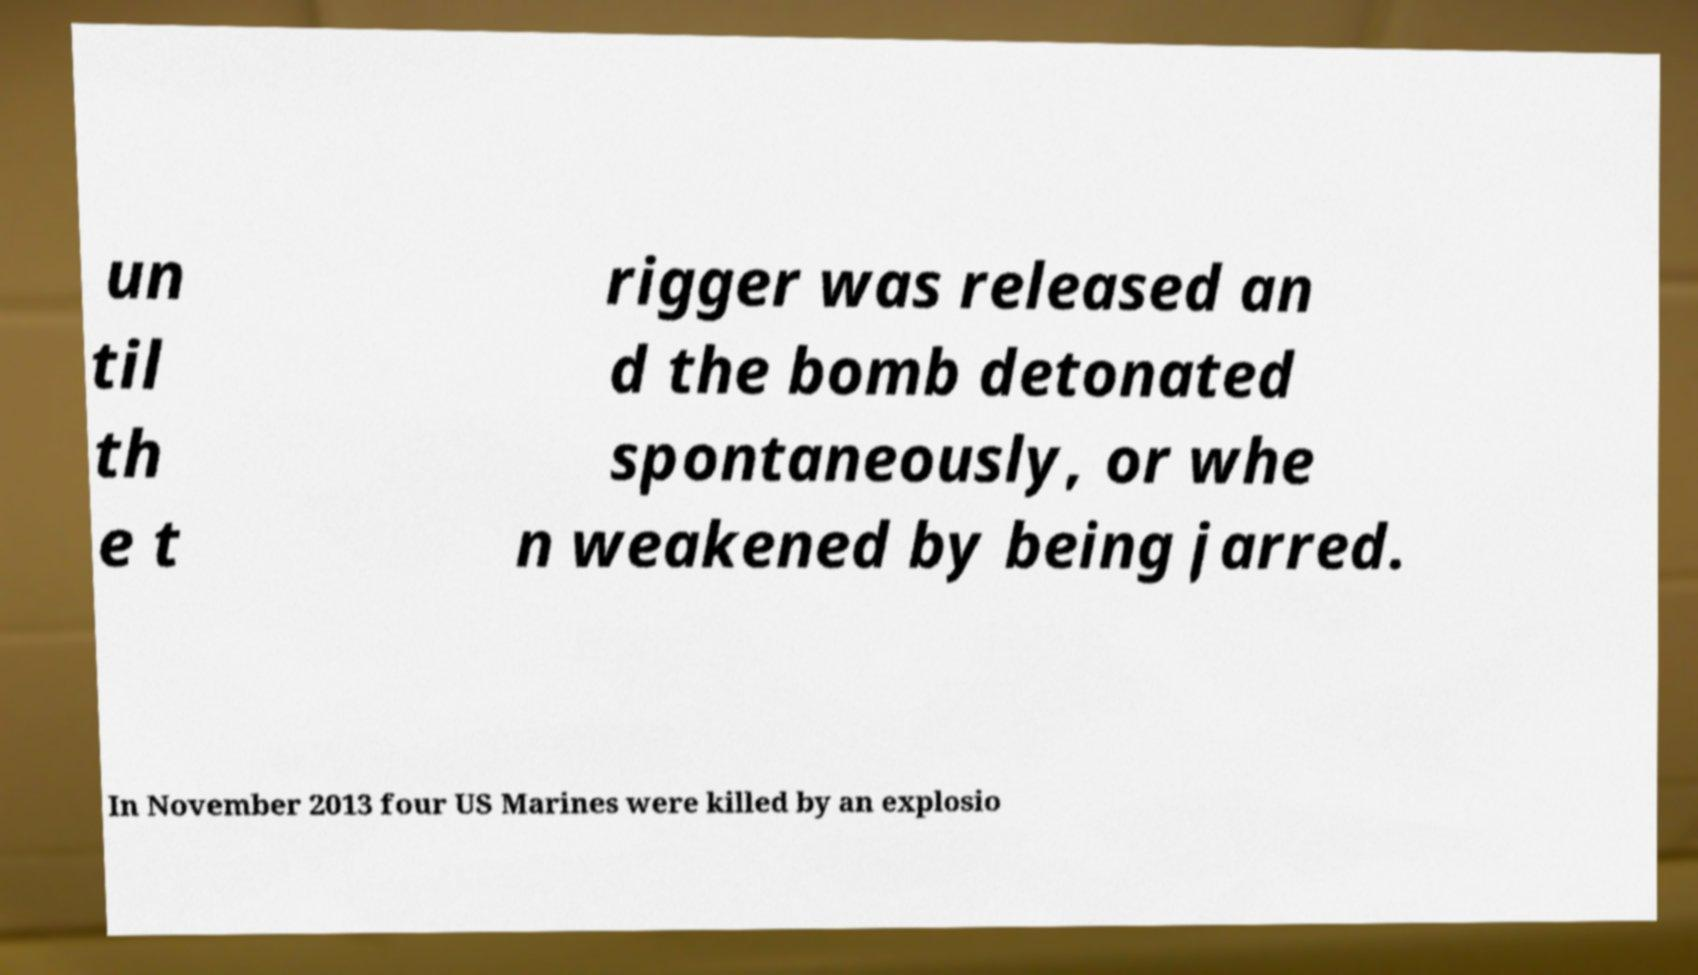Can you read and provide the text displayed in the image?This photo seems to have some interesting text. Can you extract and type it out for me? un til th e t rigger was released an d the bomb detonated spontaneously, or whe n weakened by being jarred. In November 2013 four US Marines were killed by an explosio 